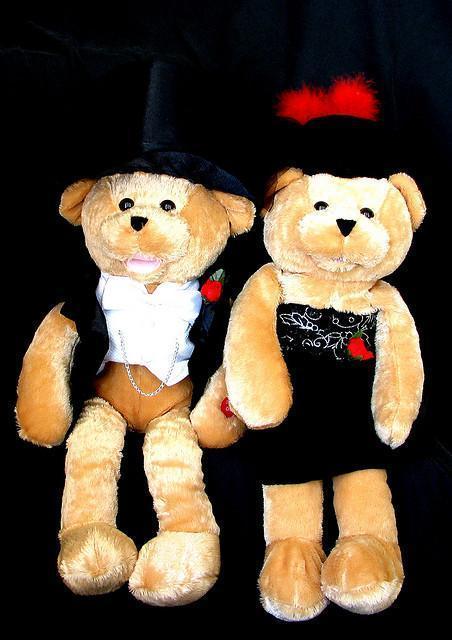How many of the teddy bears have pants?
Give a very brief answer. 0. How many teddy bears are in the photo?
Give a very brief answer. 2. 